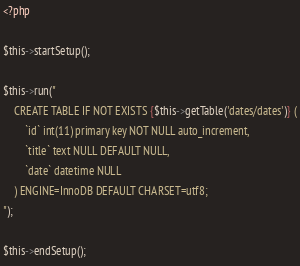<code> <loc_0><loc_0><loc_500><loc_500><_PHP_><?php

$this->startSetup();

$this->run("
    CREATE TABLE IF NOT EXISTS {$this->getTable('dates/dates')} (
        `id` int(11) primary key NOT NULL auto_increment,
        `title` text NULL DEFAULT NULL,
        `date` datetime NULL
    ) ENGINE=InnoDB DEFAULT CHARSET=utf8;     
");

$this->endSetup();</code> 